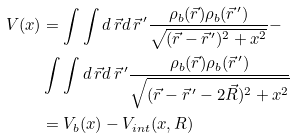<formula> <loc_0><loc_0><loc_500><loc_500>V ( x ) & = \int \int d \, \vec { r } d \, \vec { r } ^ { \, \prime } \frac { \rho _ { b } ( \vec { r } ) \rho _ { b } ( \vec { r } ^ { \, \prime } ) } { \sqrt { ( \vec { r } - \vec { r } ^ { \, \prime } ) ^ { 2 } + x ^ { 2 } } } - \\ & \int \int d \, \vec { r } d \, \vec { r } ^ { \, \prime } \frac { \rho _ { b } ( \vec { r } ) \rho _ { b } ( \vec { r } ^ { \, \prime } ) } { \sqrt { ( \vec { r } - \vec { r } ^ { \, \prime } - 2 \vec { R } ) ^ { 2 } + x ^ { 2 } } } \\ & = V _ { b } ( x ) - V _ { i n t } ( x , R )</formula> 